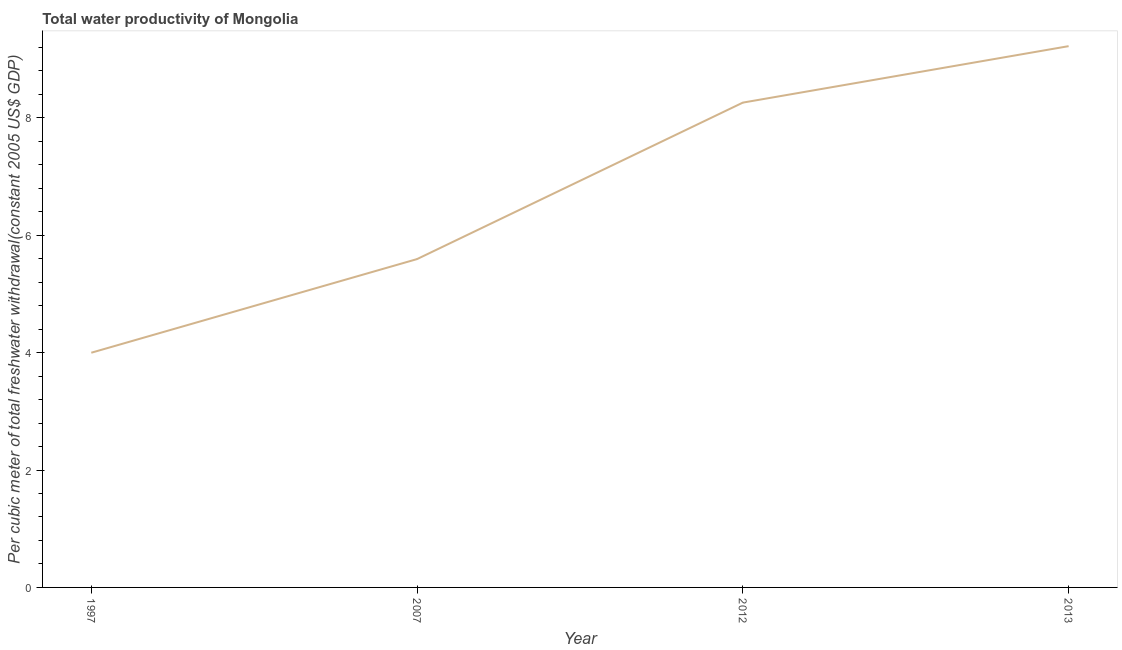What is the total water productivity in 2013?
Keep it short and to the point. 9.22. Across all years, what is the maximum total water productivity?
Give a very brief answer. 9.22. Across all years, what is the minimum total water productivity?
Provide a short and direct response. 4. In which year was the total water productivity minimum?
Provide a short and direct response. 1997. What is the sum of the total water productivity?
Offer a very short reply. 27.07. What is the difference between the total water productivity in 2007 and 2012?
Keep it short and to the point. -2.67. What is the average total water productivity per year?
Keep it short and to the point. 6.77. What is the median total water productivity?
Your answer should be very brief. 6.93. What is the ratio of the total water productivity in 2007 to that in 2013?
Your response must be concise. 0.61. Is the total water productivity in 2007 less than that in 2012?
Your answer should be very brief. Yes. What is the difference between the highest and the second highest total water productivity?
Keep it short and to the point. 0.96. What is the difference between the highest and the lowest total water productivity?
Provide a succinct answer. 5.22. In how many years, is the total water productivity greater than the average total water productivity taken over all years?
Provide a succinct answer. 2. Are the values on the major ticks of Y-axis written in scientific E-notation?
Offer a very short reply. No. Does the graph contain grids?
Offer a very short reply. No. What is the title of the graph?
Your response must be concise. Total water productivity of Mongolia. What is the label or title of the Y-axis?
Provide a succinct answer. Per cubic meter of total freshwater withdrawal(constant 2005 US$ GDP). What is the Per cubic meter of total freshwater withdrawal(constant 2005 US$ GDP) in 1997?
Give a very brief answer. 4. What is the Per cubic meter of total freshwater withdrawal(constant 2005 US$ GDP) in 2007?
Ensure brevity in your answer.  5.59. What is the Per cubic meter of total freshwater withdrawal(constant 2005 US$ GDP) of 2012?
Give a very brief answer. 8.26. What is the Per cubic meter of total freshwater withdrawal(constant 2005 US$ GDP) of 2013?
Your answer should be compact. 9.22. What is the difference between the Per cubic meter of total freshwater withdrawal(constant 2005 US$ GDP) in 1997 and 2007?
Provide a succinct answer. -1.6. What is the difference between the Per cubic meter of total freshwater withdrawal(constant 2005 US$ GDP) in 1997 and 2012?
Your answer should be compact. -4.26. What is the difference between the Per cubic meter of total freshwater withdrawal(constant 2005 US$ GDP) in 1997 and 2013?
Ensure brevity in your answer.  -5.22. What is the difference between the Per cubic meter of total freshwater withdrawal(constant 2005 US$ GDP) in 2007 and 2012?
Your response must be concise. -2.67. What is the difference between the Per cubic meter of total freshwater withdrawal(constant 2005 US$ GDP) in 2007 and 2013?
Your answer should be compact. -3.63. What is the difference between the Per cubic meter of total freshwater withdrawal(constant 2005 US$ GDP) in 2012 and 2013?
Give a very brief answer. -0.96. What is the ratio of the Per cubic meter of total freshwater withdrawal(constant 2005 US$ GDP) in 1997 to that in 2007?
Offer a very short reply. 0.71. What is the ratio of the Per cubic meter of total freshwater withdrawal(constant 2005 US$ GDP) in 1997 to that in 2012?
Your answer should be compact. 0.48. What is the ratio of the Per cubic meter of total freshwater withdrawal(constant 2005 US$ GDP) in 1997 to that in 2013?
Give a very brief answer. 0.43. What is the ratio of the Per cubic meter of total freshwater withdrawal(constant 2005 US$ GDP) in 2007 to that in 2012?
Offer a very short reply. 0.68. What is the ratio of the Per cubic meter of total freshwater withdrawal(constant 2005 US$ GDP) in 2007 to that in 2013?
Keep it short and to the point. 0.61. What is the ratio of the Per cubic meter of total freshwater withdrawal(constant 2005 US$ GDP) in 2012 to that in 2013?
Provide a succinct answer. 0.9. 